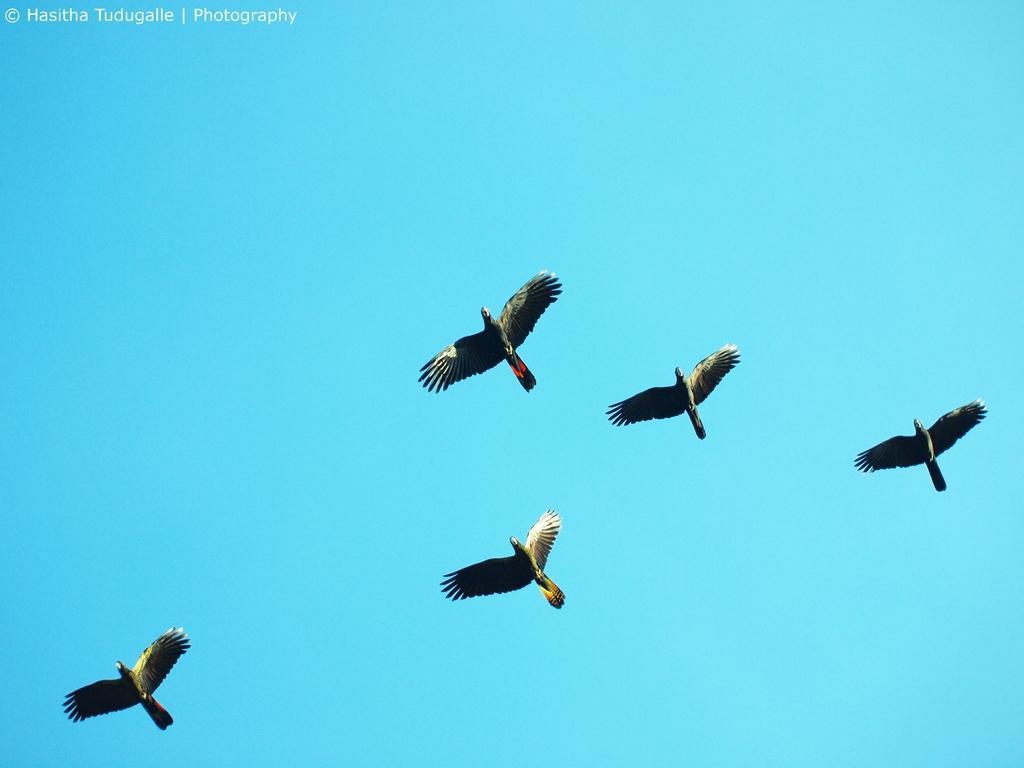In one or two sentences, can you explain what this image depicts? In this image five birds are flying in the sky. 